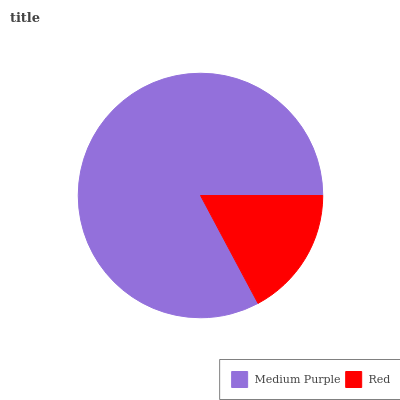Is Red the minimum?
Answer yes or no. Yes. Is Medium Purple the maximum?
Answer yes or no. Yes. Is Red the maximum?
Answer yes or no. No. Is Medium Purple greater than Red?
Answer yes or no. Yes. Is Red less than Medium Purple?
Answer yes or no. Yes. Is Red greater than Medium Purple?
Answer yes or no. No. Is Medium Purple less than Red?
Answer yes or no. No. Is Medium Purple the high median?
Answer yes or no. Yes. Is Red the low median?
Answer yes or no. Yes. Is Red the high median?
Answer yes or no. No. Is Medium Purple the low median?
Answer yes or no. No. 